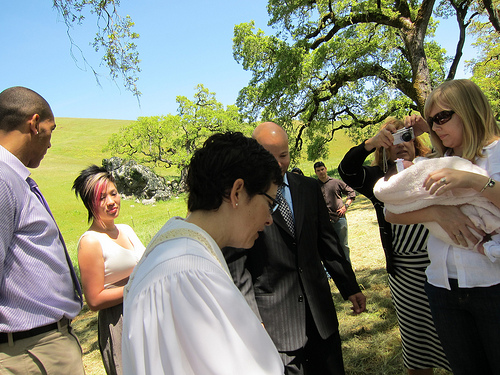<image>
Is the baby under the tree? No. The baby is not positioned under the tree. The vertical relationship between these objects is different. 